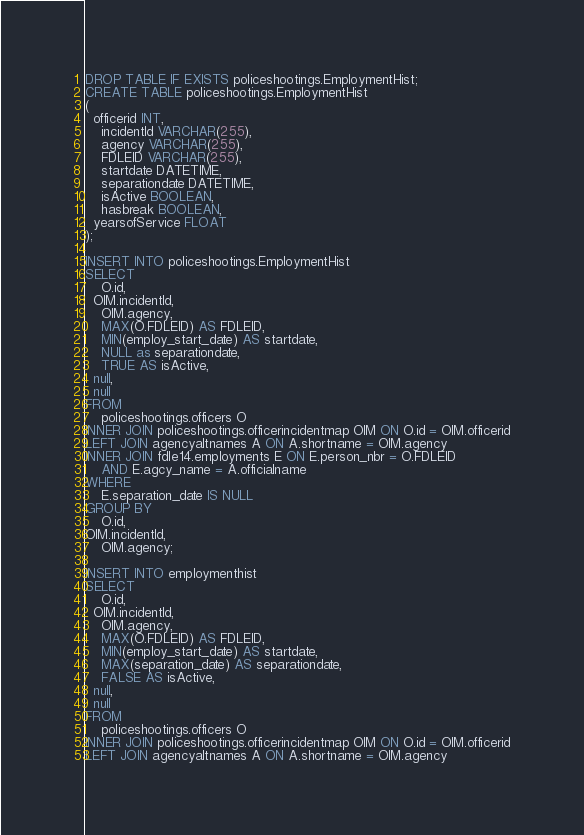<code> <loc_0><loc_0><loc_500><loc_500><_SQL_>DROP TABLE IF EXISTS policeshootings.EmploymentHist;
CREATE TABLE policeshootings.EmploymentHist
(
  officerid INT,
	incidentId VARCHAR(255),
	agency VARCHAR(255),
	FDLEID VARCHAR(255),
	startdate DATETIME,
	separationdate DATETIME,
	isActive BOOLEAN,
	hasbreak BOOLEAN,
  yearsofService FLOAT
);

INSERT INTO policeshootings.EmploymentHist
SELECT
	O.id,
  OIM.incidentId,
	OIM.agency,
	MAX(O.FDLEID) AS FDLEID, 
	MIN(employ_start_date) AS startdate,
	NULL as separationdate,
	TRUE AS isActive,
  null,
  null
FROM
	policeshootings.officers O
INNER JOIN policeshootings.officerincidentmap OIM ON O.id = OIM.officerid
LEFT JOIN agencyaltnames A ON A.shortname = OIM.agency
INNER JOIN fdle14.employments E ON E.person_nbr = O.FDLEID
	AND E.agcy_name = A.officialname
WHERE
	E.separation_date IS NULL
GROUP BY
	O.id,
OIM.incidentId,
	OIM.agency;

INSERT INTO employmenthist
SELECT
	O.id,
  OIM.incidentId,
	OIM.agency,
	MAX(O.FDLEID) AS FDLEID, 
	MIN(employ_start_date) AS startdate,
	MAX(separation_date) AS separationdate,
 	FALSE AS isActive,
  null,
  null
FROM
	policeshootings.officers O
INNER JOIN policeshootings.officerincidentmap OIM ON O.id = OIM.officerid
LEFT JOIN agencyaltnames A ON A.shortname = OIM.agency</code> 